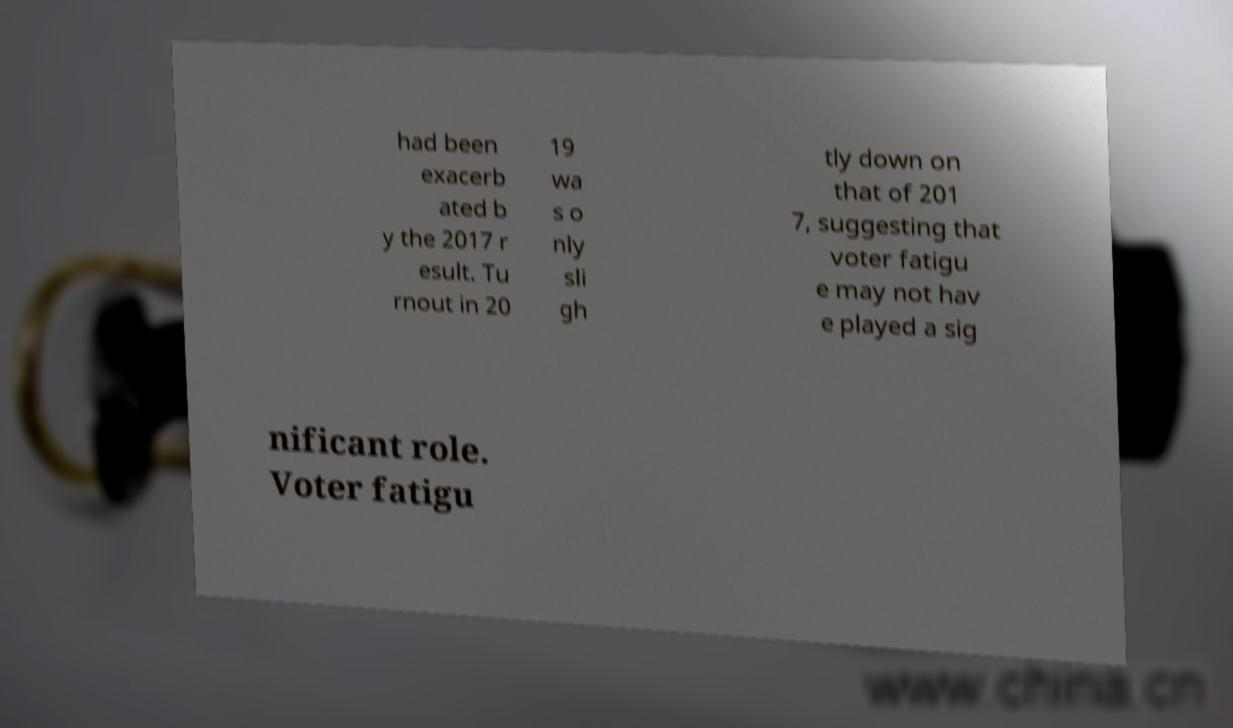Can you accurately transcribe the text from the provided image for me? had been exacerb ated b y the 2017 r esult. Tu rnout in 20 19 wa s o nly sli gh tly down on that of 201 7, suggesting that voter fatigu e may not hav e played a sig nificant role. Voter fatigu 